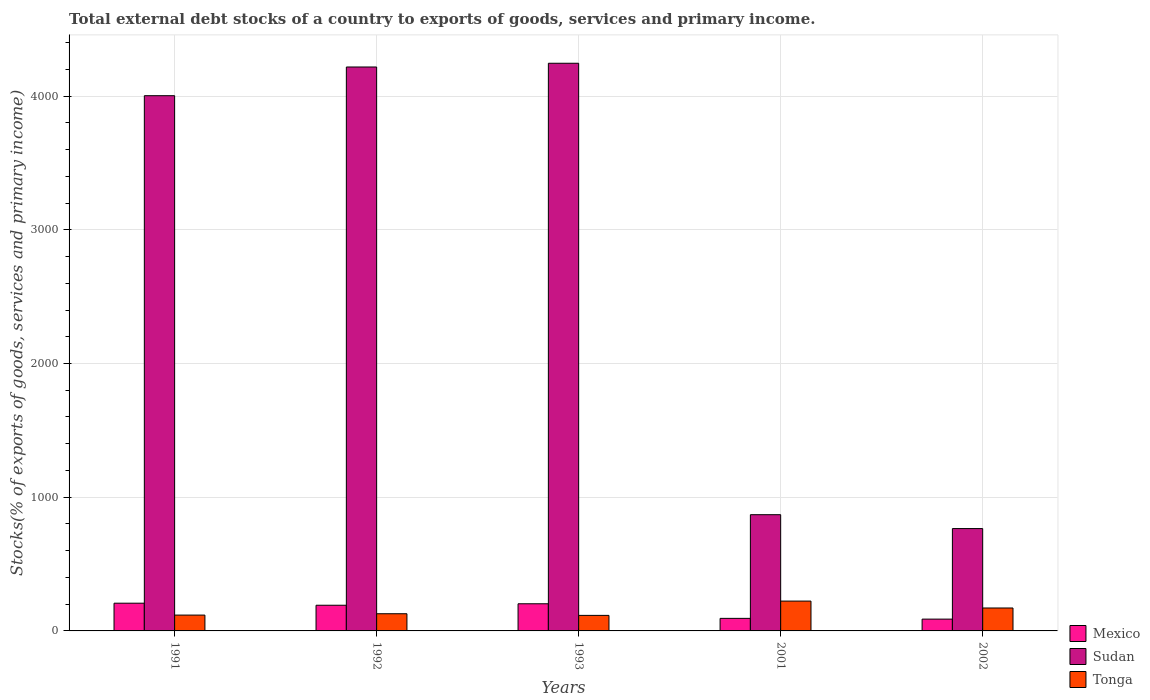How many groups of bars are there?
Offer a terse response. 5. Are the number of bars per tick equal to the number of legend labels?
Provide a short and direct response. Yes. How many bars are there on the 1st tick from the left?
Give a very brief answer. 3. How many bars are there on the 5th tick from the right?
Offer a terse response. 3. What is the label of the 2nd group of bars from the left?
Your answer should be very brief. 1992. In how many cases, is the number of bars for a given year not equal to the number of legend labels?
Your response must be concise. 0. What is the total debt stocks in Mexico in 2001?
Offer a terse response. 93.84. Across all years, what is the maximum total debt stocks in Sudan?
Give a very brief answer. 4245.39. Across all years, what is the minimum total debt stocks in Tonga?
Provide a short and direct response. 116.18. In which year was the total debt stocks in Mexico minimum?
Make the answer very short. 2002. What is the total total debt stocks in Mexico in the graph?
Offer a terse response. 784.6. What is the difference between the total debt stocks in Sudan in 1993 and that in 2002?
Your answer should be compact. 3479.96. What is the difference between the total debt stocks in Mexico in 2001 and the total debt stocks in Tonga in 2002?
Keep it short and to the point. -77.67. What is the average total debt stocks in Tonga per year?
Your answer should be compact. 151.54. In the year 1992, what is the difference between the total debt stocks in Sudan and total debt stocks in Tonga?
Your response must be concise. 4088.99. In how many years, is the total debt stocks in Sudan greater than 800 %?
Your answer should be compact. 4. What is the ratio of the total debt stocks in Mexico in 1993 to that in 2001?
Your answer should be compact. 2.16. Is the total debt stocks in Mexico in 1991 less than that in 1992?
Your answer should be very brief. No. What is the difference between the highest and the second highest total debt stocks in Sudan?
Offer a terse response. 27.87. What is the difference between the highest and the lowest total debt stocks in Sudan?
Provide a short and direct response. 3479.96. What does the 3rd bar from the left in 2002 represents?
Your answer should be compact. Tonga. What does the 2nd bar from the right in 2001 represents?
Provide a succinct answer. Sudan. Are all the bars in the graph horizontal?
Provide a short and direct response. No. How many years are there in the graph?
Offer a terse response. 5. Are the values on the major ticks of Y-axis written in scientific E-notation?
Ensure brevity in your answer.  No. Does the graph contain grids?
Provide a short and direct response. Yes. Where does the legend appear in the graph?
Keep it short and to the point. Bottom right. How are the legend labels stacked?
Your answer should be very brief. Vertical. What is the title of the graph?
Your answer should be compact. Total external debt stocks of a country to exports of goods, services and primary income. What is the label or title of the Y-axis?
Make the answer very short. Stocks(% of exports of goods, services and primary income). What is the Stocks(% of exports of goods, services and primary income) in Mexico in 1991?
Your answer should be very brief. 207.37. What is the Stocks(% of exports of goods, services and primary income) in Sudan in 1991?
Provide a succinct answer. 4002.85. What is the Stocks(% of exports of goods, services and primary income) in Tonga in 1991?
Give a very brief answer. 118.39. What is the Stocks(% of exports of goods, services and primary income) in Mexico in 1992?
Your answer should be compact. 192.1. What is the Stocks(% of exports of goods, services and primary income) of Sudan in 1992?
Keep it short and to the point. 4217.51. What is the Stocks(% of exports of goods, services and primary income) of Tonga in 1992?
Ensure brevity in your answer.  128.53. What is the Stocks(% of exports of goods, services and primary income) in Mexico in 1993?
Provide a short and direct response. 203.01. What is the Stocks(% of exports of goods, services and primary income) in Sudan in 1993?
Offer a terse response. 4245.39. What is the Stocks(% of exports of goods, services and primary income) of Tonga in 1993?
Provide a succinct answer. 116.18. What is the Stocks(% of exports of goods, services and primary income) of Mexico in 2001?
Provide a succinct answer. 93.84. What is the Stocks(% of exports of goods, services and primary income) in Sudan in 2001?
Make the answer very short. 869.18. What is the Stocks(% of exports of goods, services and primary income) of Tonga in 2001?
Provide a succinct answer. 223.1. What is the Stocks(% of exports of goods, services and primary income) in Mexico in 2002?
Offer a terse response. 88.27. What is the Stocks(% of exports of goods, services and primary income) in Sudan in 2002?
Your response must be concise. 765.42. What is the Stocks(% of exports of goods, services and primary income) in Tonga in 2002?
Ensure brevity in your answer.  171.51. Across all years, what is the maximum Stocks(% of exports of goods, services and primary income) in Mexico?
Offer a terse response. 207.37. Across all years, what is the maximum Stocks(% of exports of goods, services and primary income) of Sudan?
Make the answer very short. 4245.39. Across all years, what is the maximum Stocks(% of exports of goods, services and primary income) of Tonga?
Your answer should be compact. 223.1. Across all years, what is the minimum Stocks(% of exports of goods, services and primary income) in Mexico?
Offer a terse response. 88.27. Across all years, what is the minimum Stocks(% of exports of goods, services and primary income) in Sudan?
Give a very brief answer. 765.42. Across all years, what is the minimum Stocks(% of exports of goods, services and primary income) in Tonga?
Offer a terse response. 116.18. What is the total Stocks(% of exports of goods, services and primary income) of Mexico in the graph?
Your answer should be compact. 784.6. What is the total Stocks(% of exports of goods, services and primary income) of Sudan in the graph?
Give a very brief answer. 1.41e+04. What is the total Stocks(% of exports of goods, services and primary income) in Tonga in the graph?
Give a very brief answer. 757.7. What is the difference between the Stocks(% of exports of goods, services and primary income) of Mexico in 1991 and that in 1992?
Your answer should be compact. 15.27. What is the difference between the Stocks(% of exports of goods, services and primary income) of Sudan in 1991 and that in 1992?
Your answer should be compact. -214.67. What is the difference between the Stocks(% of exports of goods, services and primary income) of Tonga in 1991 and that in 1992?
Your answer should be very brief. -10.14. What is the difference between the Stocks(% of exports of goods, services and primary income) of Mexico in 1991 and that in 1993?
Provide a succinct answer. 4.36. What is the difference between the Stocks(% of exports of goods, services and primary income) of Sudan in 1991 and that in 1993?
Ensure brevity in your answer.  -242.54. What is the difference between the Stocks(% of exports of goods, services and primary income) of Tonga in 1991 and that in 1993?
Offer a terse response. 2.21. What is the difference between the Stocks(% of exports of goods, services and primary income) in Mexico in 1991 and that in 2001?
Provide a succinct answer. 113.54. What is the difference between the Stocks(% of exports of goods, services and primary income) of Sudan in 1991 and that in 2001?
Offer a terse response. 3133.67. What is the difference between the Stocks(% of exports of goods, services and primary income) in Tonga in 1991 and that in 2001?
Keep it short and to the point. -104.72. What is the difference between the Stocks(% of exports of goods, services and primary income) of Mexico in 1991 and that in 2002?
Provide a short and direct response. 119.11. What is the difference between the Stocks(% of exports of goods, services and primary income) in Sudan in 1991 and that in 2002?
Offer a terse response. 3237.43. What is the difference between the Stocks(% of exports of goods, services and primary income) in Tonga in 1991 and that in 2002?
Offer a terse response. -53.13. What is the difference between the Stocks(% of exports of goods, services and primary income) of Mexico in 1992 and that in 1993?
Provide a succinct answer. -10.91. What is the difference between the Stocks(% of exports of goods, services and primary income) of Sudan in 1992 and that in 1993?
Provide a succinct answer. -27.87. What is the difference between the Stocks(% of exports of goods, services and primary income) of Tonga in 1992 and that in 1993?
Give a very brief answer. 12.35. What is the difference between the Stocks(% of exports of goods, services and primary income) in Mexico in 1992 and that in 2001?
Your response must be concise. 98.26. What is the difference between the Stocks(% of exports of goods, services and primary income) in Sudan in 1992 and that in 2001?
Give a very brief answer. 3348.34. What is the difference between the Stocks(% of exports of goods, services and primary income) in Tonga in 1992 and that in 2001?
Your answer should be very brief. -94.58. What is the difference between the Stocks(% of exports of goods, services and primary income) in Mexico in 1992 and that in 2002?
Make the answer very short. 103.84. What is the difference between the Stocks(% of exports of goods, services and primary income) of Sudan in 1992 and that in 2002?
Provide a succinct answer. 3452.09. What is the difference between the Stocks(% of exports of goods, services and primary income) of Tonga in 1992 and that in 2002?
Make the answer very short. -42.99. What is the difference between the Stocks(% of exports of goods, services and primary income) of Mexico in 1993 and that in 2001?
Keep it short and to the point. 109.18. What is the difference between the Stocks(% of exports of goods, services and primary income) of Sudan in 1993 and that in 2001?
Make the answer very short. 3376.21. What is the difference between the Stocks(% of exports of goods, services and primary income) of Tonga in 1993 and that in 2001?
Your response must be concise. -106.92. What is the difference between the Stocks(% of exports of goods, services and primary income) in Mexico in 1993 and that in 2002?
Your answer should be compact. 114.75. What is the difference between the Stocks(% of exports of goods, services and primary income) in Sudan in 1993 and that in 2002?
Offer a very short reply. 3479.96. What is the difference between the Stocks(% of exports of goods, services and primary income) in Tonga in 1993 and that in 2002?
Your answer should be compact. -55.33. What is the difference between the Stocks(% of exports of goods, services and primary income) of Mexico in 2001 and that in 2002?
Give a very brief answer. 5.57. What is the difference between the Stocks(% of exports of goods, services and primary income) of Sudan in 2001 and that in 2002?
Ensure brevity in your answer.  103.76. What is the difference between the Stocks(% of exports of goods, services and primary income) in Tonga in 2001 and that in 2002?
Offer a terse response. 51.59. What is the difference between the Stocks(% of exports of goods, services and primary income) in Mexico in 1991 and the Stocks(% of exports of goods, services and primary income) in Sudan in 1992?
Give a very brief answer. -4010.14. What is the difference between the Stocks(% of exports of goods, services and primary income) of Mexico in 1991 and the Stocks(% of exports of goods, services and primary income) of Tonga in 1992?
Make the answer very short. 78.85. What is the difference between the Stocks(% of exports of goods, services and primary income) of Sudan in 1991 and the Stocks(% of exports of goods, services and primary income) of Tonga in 1992?
Offer a terse response. 3874.32. What is the difference between the Stocks(% of exports of goods, services and primary income) of Mexico in 1991 and the Stocks(% of exports of goods, services and primary income) of Sudan in 1993?
Offer a very short reply. -4038.01. What is the difference between the Stocks(% of exports of goods, services and primary income) in Mexico in 1991 and the Stocks(% of exports of goods, services and primary income) in Tonga in 1993?
Your answer should be compact. 91.2. What is the difference between the Stocks(% of exports of goods, services and primary income) of Sudan in 1991 and the Stocks(% of exports of goods, services and primary income) of Tonga in 1993?
Offer a very short reply. 3886.67. What is the difference between the Stocks(% of exports of goods, services and primary income) of Mexico in 1991 and the Stocks(% of exports of goods, services and primary income) of Sudan in 2001?
Ensure brevity in your answer.  -661.8. What is the difference between the Stocks(% of exports of goods, services and primary income) of Mexico in 1991 and the Stocks(% of exports of goods, services and primary income) of Tonga in 2001?
Your answer should be compact. -15.73. What is the difference between the Stocks(% of exports of goods, services and primary income) in Sudan in 1991 and the Stocks(% of exports of goods, services and primary income) in Tonga in 2001?
Your response must be concise. 3779.75. What is the difference between the Stocks(% of exports of goods, services and primary income) in Mexico in 1991 and the Stocks(% of exports of goods, services and primary income) in Sudan in 2002?
Your response must be concise. -558.05. What is the difference between the Stocks(% of exports of goods, services and primary income) in Mexico in 1991 and the Stocks(% of exports of goods, services and primary income) in Tonga in 2002?
Make the answer very short. 35.86. What is the difference between the Stocks(% of exports of goods, services and primary income) in Sudan in 1991 and the Stocks(% of exports of goods, services and primary income) in Tonga in 2002?
Offer a very short reply. 3831.34. What is the difference between the Stocks(% of exports of goods, services and primary income) of Mexico in 1992 and the Stocks(% of exports of goods, services and primary income) of Sudan in 1993?
Keep it short and to the point. -4053.28. What is the difference between the Stocks(% of exports of goods, services and primary income) in Mexico in 1992 and the Stocks(% of exports of goods, services and primary income) in Tonga in 1993?
Keep it short and to the point. 75.93. What is the difference between the Stocks(% of exports of goods, services and primary income) of Sudan in 1992 and the Stocks(% of exports of goods, services and primary income) of Tonga in 1993?
Keep it short and to the point. 4101.34. What is the difference between the Stocks(% of exports of goods, services and primary income) in Mexico in 1992 and the Stocks(% of exports of goods, services and primary income) in Sudan in 2001?
Provide a short and direct response. -677.08. What is the difference between the Stocks(% of exports of goods, services and primary income) of Mexico in 1992 and the Stocks(% of exports of goods, services and primary income) of Tonga in 2001?
Provide a succinct answer. -31. What is the difference between the Stocks(% of exports of goods, services and primary income) in Sudan in 1992 and the Stocks(% of exports of goods, services and primary income) in Tonga in 2001?
Offer a terse response. 3994.41. What is the difference between the Stocks(% of exports of goods, services and primary income) in Mexico in 1992 and the Stocks(% of exports of goods, services and primary income) in Sudan in 2002?
Your answer should be compact. -573.32. What is the difference between the Stocks(% of exports of goods, services and primary income) of Mexico in 1992 and the Stocks(% of exports of goods, services and primary income) of Tonga in 2002?
Offer a terse response. 20.59. What is the difference between the Stocks(% of exports of goods, services and primary income) of Sudan in 1992 and the Stocks(% of exports of goods, services and primary income) of Tonga in 2002?
Ensure brevity in your answer.  4046. What is the difference between the Stocks(% of exports of goods, services and primary income) in Mexico in 1993 and the Stocks(% of exports of goods, services and primary income) in Sudan in 2001?
Keep it short and to the point. -666.16. What is the difference between the Stocks(% of exports of goods, services and primary income) of Mexico in 1993 and the Stocks(% of exports of goods, services and primary income) of Tonga in 2001?
Your answer should be very brief. -20.09. What is the difference between the Stocks(% of exports of goods, services and primary income) in Sudan in 1993 and the Stocks(% of exports of goods, services and primary income) in Tonga in 2001?
Provide a succinct answer. 4022.28. What is the difference between the Stocks(% of exports of goods, services and primary income) of Mexico in 1993 and the Stocks(% of exports of goods, services and primary income) of Sudan in 2002?
Make the answer very short. -562.41. What is the difference between the Stocks(% of exports of goods, services and primary income) in Mexico in 1993 and the Stocks(% of exports of goods, services and primary income) in Tonga in 2002?
Provide a short and direct response. 31.5. What is the difference between the Stocks(% of exports of goods, services and primary income) in Sudan in 1993 and the Stocks(% of exports of goods, services and primary income) in Tonga in 2002?
Ensure brevity in your answer.  4073.87. What is the difference between the Stocks(% of exports of goods, services and primary income) in Mexico in 2001 and the Stocks(% of exports of goods, services and primary income) in Sudan in 2002?
Provide a short and direct response. -671.58. What is the difference between the Stocks(% of exports of goods, services and primary income) of Mexico in 2001 and the Stocks(% of exports of goods, services and primary income) of Tonga in 2002?
Offer a very short reply. -77.67. What is the difference between the Stocks(% of exports of goods, services and primary income) in Sudan in 2001 and the Stocks(% of exports of goods, services and primary income) in Tonga in 2002?
Ensure brevity in your answer.  697.67. What is the average Stocks(% of exports of goods, services and primary income) in Mexico per year?
Your answer should be compact. 156.92. What is the average Stocks(% of exports of goods, services and primary income) in Sudan per year?
Make the answer very short. 2820.07. What is the average Stocks(% of exports of goods, services and primary income) in Tonga per year?
Your answer should be compact. 151.54. In the year 1991, what is the difference between the Stocks(% of exports of goods, services and primary income) of Mexico and Stocks(% of exports of goods, services and primary income) of Sudan?
Ensure brevity in your answer.  -3795.47. In the year 1991, what is the difference between the Stocks(% of exports of goods, services and primary income) in Mexico and Stocks(% of exports of goods, services and primary income) in Tonga?
Your answer should be very brief. 88.99. In the year 1991, what is the difference between the Stocks(% of exports of goods, services and primary income) of Sudan and Stocks(% of exports of goods, services and primary income) of Tonga?
Your answer should be very brief. 3884.46. In the year 1992, what is the difference between the Stocks(% of exports of goods, services and primary income) in Mexico and Stocks(% of exports of goods, services and primary income) in Sudan?
Offer a terse response. -4025.41. In the year 1992, what is the difference between the Stocks(% of exports of goods, services and primary income) in Mexico and Stocks(% of exports of goods, services and primary income) in Tonga?
Give a very brief answer. 63.58. In the year 1992, what is the difference between the Stocks(% of exports of goods, services and primary income) of Sudan and Stocks(% of exports of goods, services and primary income) of Tonga?
Offer a terse response. 4088.99. In the year 1993, what is the difference between the Stocks(% of exports of goods, services and primary income) of Mexico and Stocks(% of exports of goods, services and primary income) of Sudan?
Give a very brief answer. -4042.37. In the year 1993, what is the difference between the Stocks(% of exports of goods, services and primary income) in Mexico and Stocks(% of exports of goods, services and primary income) in Tonga?
Your answer should be very brief. 86.84. In the year 1993, what is the difference between the Stocks(% of exports of goods, services and primary income) of Sudan and Stocks(% of exports of goods, services and primary income) of Tonga?
Provide a succinct answer. 4129.21. In the year 2001, what is the difference between the Stocks(% of exports of goods, services and primary income) of Mexico and Stocks(% of exports of goods, services and primary income) of Sudan?
Make the answer very short. -775.34. In the year 2001, what is the difference between the Stocks(% of exports of goods, services and primary income) in Mexico and Stocks(% of exports of goods, services and primary income) in Tonga?
Your response must be concise. -129.26. In the year 2001, what is the difference between the Stocks(% of exports of goods, services and primary income) of Sudan and Stocks(% of exports of goods, services and primary income) of Tonga?
Give a very brief answer. 646.08. In the year 2002, what is the difference between the Stocks(% of exports of goods, services and primary income) in Mexico and Stocks(% of exports of goods, services and primary income) in Sudan?
Provide a succinct answer. -677.16. In the year 2002, what is the difference between the Stocks(% of exports of goods, services and primary income) in Mexico and Stocks(% of exports of goods, services and primary income) in Tonga?
Ensure brevity in your answer.  -83.24. In the year 2002, what is the difference between the Stocks(% of exports of goods, services and primary income) in Sudan and Stocks(% of exports of goods, services and primary income) in Tonga?
Your answer should be very brief. 593.91. What is the ratio of the Stocks(% of exports of goods, services and primary income) of Mexico in 1991 to that in 1992?
Offer a terse response. 1.08. What is the ratio of the Stocks(% of exports of goods, services and primary income) in Sudan in 1991 to that in 1992?
Ensure brevity in your answer.  0.95. What is the ratio of the Stocks(% of exports of goods, services and primary income) in Tonga in 1991 to that in 1992?
Keep it short and to the point. 0.92. What is the ratio of the Stocks(% of exports of goods, services and primary income) in Mexico in 1991 to that in 1993?
Ensure brevity in your answer.  1.02. What is the ratio of the Stocks(% of exports of goods, services and primary income) in Sudan in 1991 to that in 1993?
Keep it short and to the point. 0.94. What is the ratio of the Stocks(% of exports of goods, services and primary income) of Tonga in 1991 to that in 1993?
Your answer should be compact. 1.02. What is the ratio of the Stocks(% of exports of goods, services and primary income) of Mexico in 1991 to that in 2001?
Your response must be concise. 2.21. What is the ratio of the Stocks(% of exports of goods, services and primary income) in Sudan in 1991 to that in 2001?
Your response must be concise. 4.61. What is the ratio of the Stocks(% of exports of goods, services and primary income) in Tonga in 1991 to that in 2001?
Offer a very short reply. 0.53. What is the ratio of the Stocks(% of exports of goods, services and primary income) in Mexico in 1991 to that in 2002?
Provide a short and direct response. 2.35. What is the ratio of the Stocks(% of exports of goods, services and primary income) in Sudan in 1991 to that in 2002?
Your answer should be very brief. 5.23. What is the ratio of the Stocks(% of exports of goods, services and primary income) in Tonga in 1991 to that in 2002?
Provide a short and direct response. 0.69. What is the ratio of the Stocks(% of exports of goods, services and primary income) in Mexico in 1992 to that in 1993?
Offer a very short reply. 0.95. What is the ratio of the Stocks(% of exports of goods, services and primary income) of Sudan in 1992 to that in 1993?
Provide a succinct answer. 0.99. What is the ratio of the Stocks(% of exports of goods, services and primary income) of Tonga in 1992 to that in 1993?
Provide a succinct answer. 1.11. What is the ratio of the Stocks(% of exports of goods, services and primary income) of Mexico in 1992 to that in 2001?
Make the answer very short. 2.05. What is the ratio of the Stocks(% of exports of goods, services and primary income) of Sudan in 1992 to that in 2001?
Your response must be concise. 4.85. What is the ratio of the Stocks(% of exports of goods, services and primary income) of Tonga in 1992 to that in 2001?
Ensure brevity in your answer.  0.58. What is the ratio of the Stocks(% of exports of goods, services and primary income) of Mexico in 1992 to that in 2002?
Keep it short and to the point. 2.18. What is the ratio of the Stocks(% of exports of goods, services and primary income) of Sudan in 1992 to that in 2002?
Give a very brief answer. 5.51. What is the ratio of the Stocks(% of exports of goods, services and primary income) of Tonga in 1992 to that in 2002?
Your answer should be very brief. 0.75. What is the ratio of the Stocks(% of exports of goods, services and primary income) in Mexico in 1993 to that in 2001?
Offer a very short reply. 2.16. What is the ratio of the Stocks(% of exports of goods, services and primary income) in Sudan in 1993 to that in 2001?
Your answer should be very brief. 4.88. What is the ratio of the Stocks(% of exports of goods, services and primary income) of Tonga in 1993 to that in 2001?
Keep it short and to the point. 0.52. What is the ratio of the Stocks(% of exports of goods, services and primary income) in Mexico in 1993 to that in 2002?
Make the answer very short. 2.3. What is the ratio of the Stocks(% of exports of goods, services and primary income) in Sudan in 1993 to that in 2002?
Your response must be concise. 5.55. What is the ratio of the Stocks(% of exports of goods, services and primary income) of Tonga in 1993 to that in 2002?
Your response must be concise. 0.68. What is the ratio of the Stocks(% of exports of goods, services and primary income) of Mexico in 2001 to that in 2002?
Provide a succinct answer. 1.06. What is the ratio of the Stocks(% of exports of goods, services and primary income) in Sudan in 2001 to that in 2002?
Give a very brief answer. 1.14. What is the ratio of the Stocks(% of exports of goods, services and primary income) in Tonga in 2001 to that in 2002?
Offer a terse response. 1.3. What is the difference between the highest and the second highest Stocks(% of exports of goods, services and primary income) of Mexico?
Ensure brevity in your answer.  4.36. What is the difference between the highest and the second highest Stocks(% of exports of goods, services and primary income) in Sudan?
Your answer should be very brief. 27.87. What is the difference between the highest and the second highest Stocks(% of exports of goods, services and primary income) in Tonga?
Provide a short and direct response. 51.59. What is the difference between the highest and the lowest Stocks(% of exports of goods, services and primary income) in Mexico?
Your answer should be compact. 119.11. What is the difference between the highest and the lowest Stocks(% of exports of goods, services and primary income) in Sudan?
Your response must be concise. 3479.96. What is the difference between the highest and the lowest Stocks(% of exports of goods, services and primary income) of Tonga?
Keep it short and to the point. 106.92. 